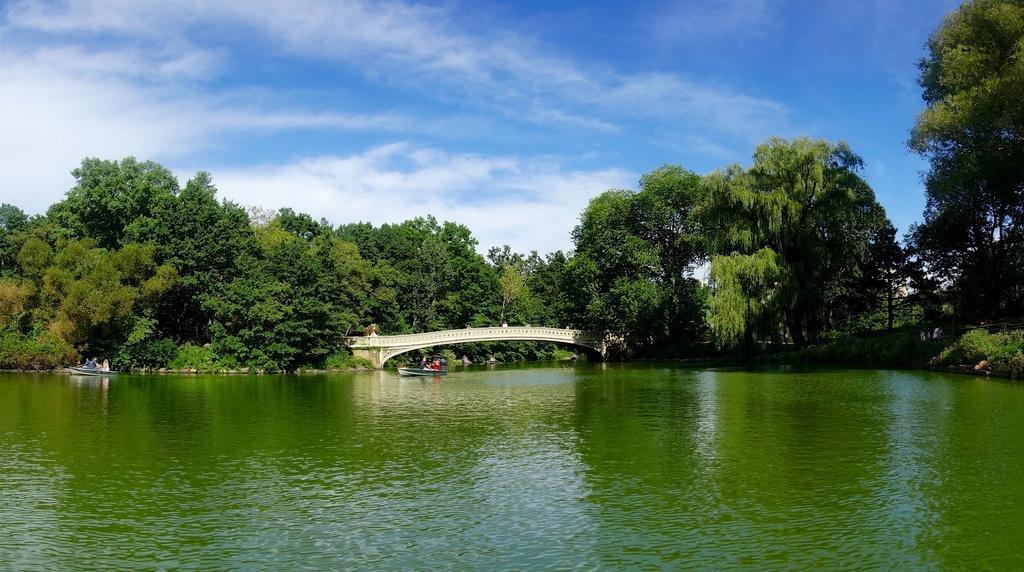Could you give a brief overview of what you see in this image? There is a lake at the bottom of this image and there is a bridge and some trees in the background. There is a cloudy sky at the top of this image. 